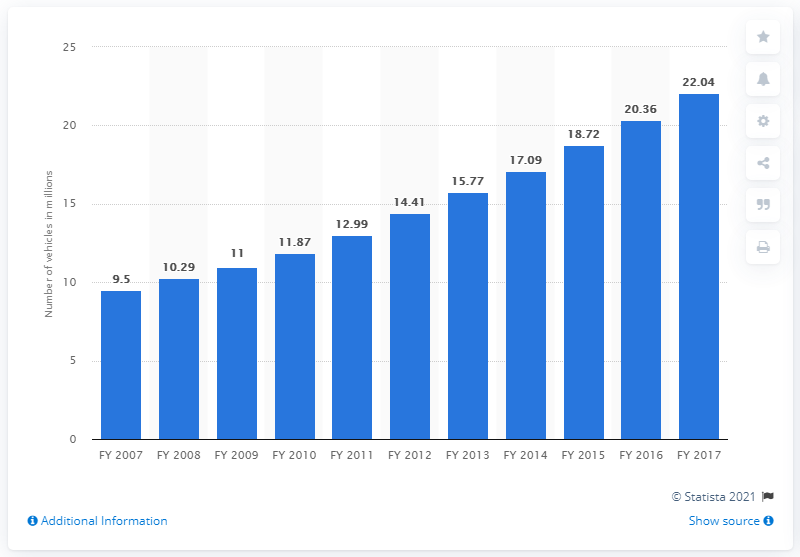Mention a couple of crucial points in this snapshot. There were 22,040 registered vehicles in Gujarat at the end of the fiscal year 2017. 